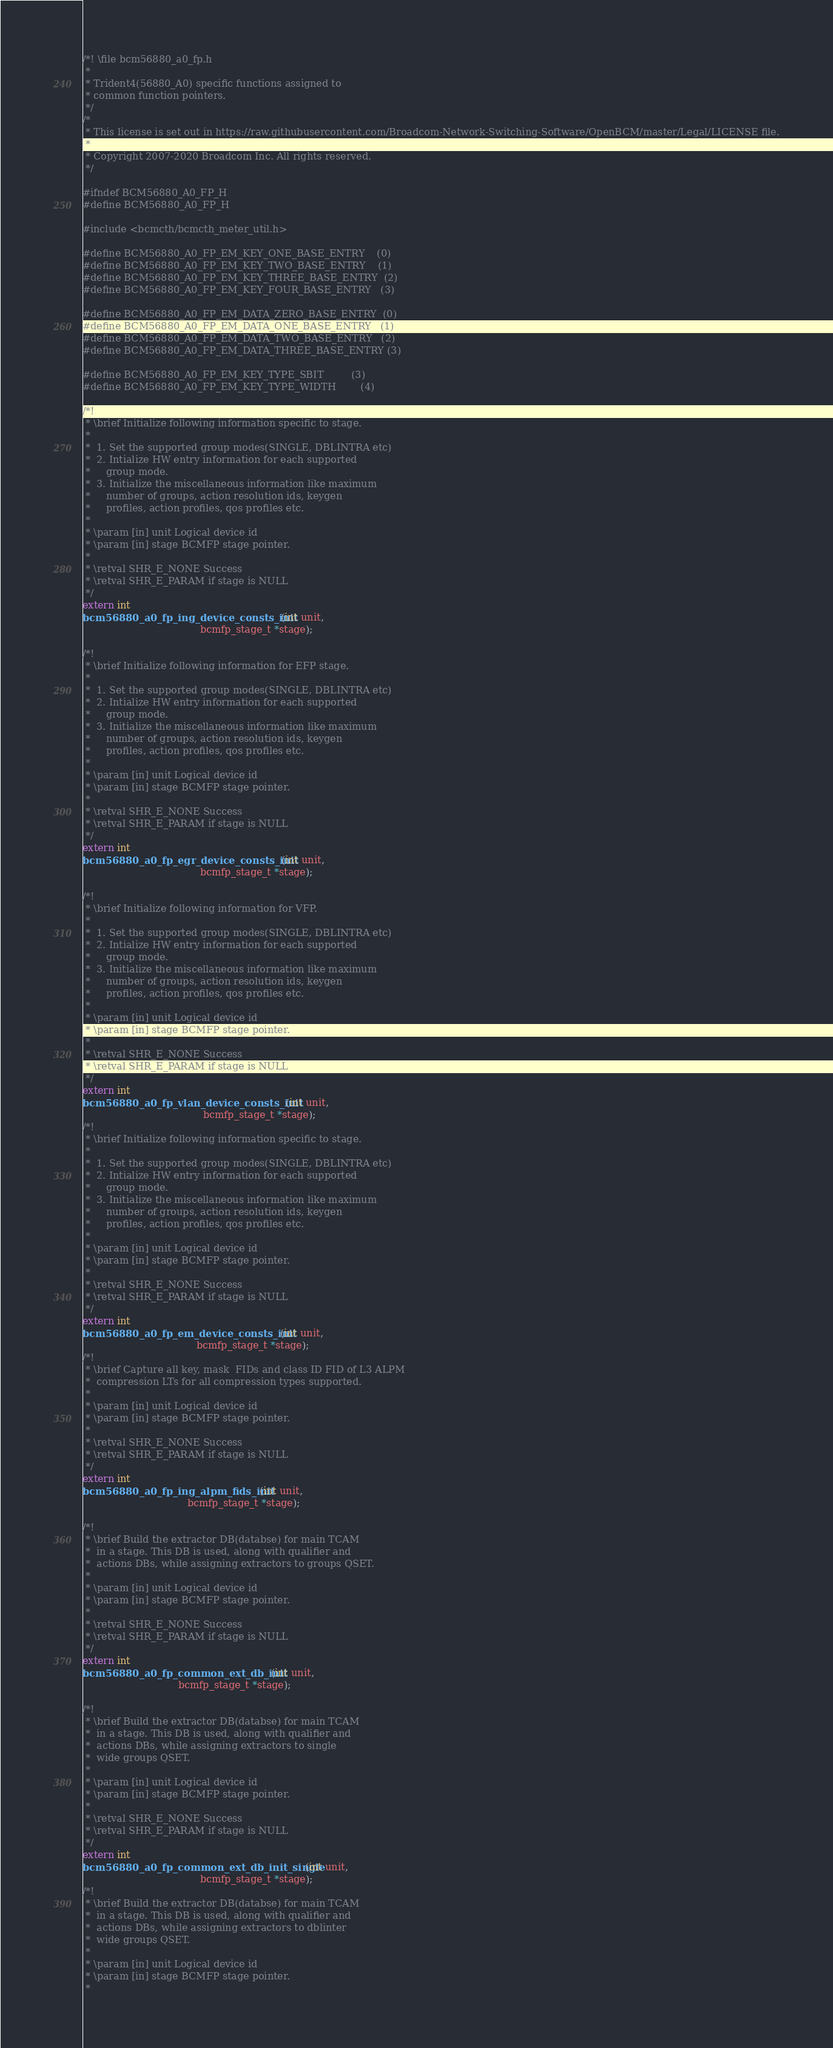Convert code to text. <code><loc_0><loc_0><loc_500><loc_500><_C_>/*! \file bcm56880_a0_fp.h
 *
 * Trident4(56880_A0) specific functions assigned to
 * common function pointers.
 */
/*
 * This license is set out in https://raw.githubusercontent.com/Broadcom-Network-Switching-Software/OpenBCM/master/Legal/LICENSE file.
 * 
 * Copyright 2007-2020 Broadcom Inc. All rights reserved.
 */

#ifndef BCM56880_A0_FP_H
#define BCM56880_A0_FP_H

#include <bcmcth/bcmcth_meter_util.h>

#define BCM56880_A0_FP_EM_KEY_ONE_BASE_ENTRY    (0)
#define BCM56880_A0_FP_EM_KEY_TWO_BASE_ENTRY    (1)
#define BCM56880_A0_FP_EM_KEY_THREE_BASE_ENTRY  (2)
#define BCM56880_A0_FP_EM_KEY_FOUR_BASE_ENTRY   (3)

#define BCM56880_A0_FP_EM_DATA_ZERO_BASE_ENTRY  (0)
#define BCM56880_A0_FP_EM_DATA_ONE_BASE_ENTRY   (1)
#define BCM56880_A0_FP_EM_DATA_TWO_BASE_ENTRY   (2)
#define BCM56880_A0_FP_EM_DATA_THREE_BASE_ENTRY (3)

#define BCM56880_A0_FP_EM_KEY_TYPE_SBIT         (3)
#define BCM56880_A0_FP_EM_KEY_TYPE_WIDTH        (4)

/*!
 * \brief Initialize following information specific to stage.
 *
 *  1. Set the supported group modes(SINGLE, DBLINTRA etc)
 *  2. Intialize HW entry information for each supported
 *     group mode.
 *  3. Initialize the miscellaneous information like maximum
 *     number of groups, action resolution ids, keygen
 *     profiles, action profiles, qos profiles etc.
 *
 * \param [in] unit Logical device id
 * \param [in] stage BCMFP stage pointer.
 *
 * \retval SHR_E_NONE Success
 * \retval SHR_E_PARAM if stage is NULL
 */
extern int
bcm56880_a0_fp_ing_device_consts_init(int unit,
                                      bcmfp_stage_t *stage);

/*!
 * \brief Initialize following information for EFP stage.
 *
 *  1. Set the supported group modes(SINGLE, DBLINTRA etc)
 *  2. Intialize HW entry information for each supported
 *     group mode.
 *  3. Initialize the miscellaneous information like maximum
 *     number of groups, action resolution ids, keygen
 *     profiles, action profiles, qos profiles etc.
 *
 * \param [in] unit Logical device id
 * \param [in] stage BCMFP stage pointer.
 *
 * \retval SHR_E_NONE Success
 * \retval SHR_E_PARAM if stage is NULL
 */
extern int
bcm56880_a0_fp_egr_device_consts_init(int unit,
                                      bcmfp_stage_t *stage);

/*!
 * \brief Initialize following information for VFP.
 *
 *  1. Set the supported group modes(SINGLE, DBLINTRA etc)
 *  2. Intialize HW entry information for each supported
 *     group mode.
 *  3. Initialize the miscellaneous information like maximum
 *     number of groups, action resolution ids, keygen
 *     profiles, action profiles, qos profiles etc.
 *
 * \param [in] unit Logical device id
 * \param [in] stage BCMFP stage pointer.
 *
 * \retval SHR_E_NONE Success
 * \retval SHR_E_PARAM if stage is NULL
 */
extern int
bcm56880_a0_fp_vlan_device_consts_init(int unit,
                                       bcmfp_stage_t *stage);
/*!
 * \brief Initialize following information specific to stage.
 *
 *  1. Set the supported group modes(SINGLE, DBLINTRA etc)
 *  2. Intialize HW entry information for each supported
 *     group mode.
 *  3. Initialize the miscellaneous information like maximum
 *     number of groups, action resolution ids, keygen
 *     profiles, action profiles, qos profiles etc.
 *
 * \param [in] unit Logical device id
 * \param [in] stage BCMFP stage pointer.
 *
 * \retval SHR_E_NONE Success
 * \retval SHR_E_PARAM if stage is NULL
 */
extern int
bcm56880_a0_fp_em_device_consts_init(int unit,
                                     bcmfp_stage_t *stage);
/*!
 * \brief Capture all key, mask  FIDs and class ID FID of L3 ALPM
 *  compression LTs for all compression types supported.
 *
 * \param [in] unit Logical device id
 * \param [in] stage BCMFP stage pointer.
 *
 * \retval SHR_E_NONE Success
 * \retval SHR_E_PARAM if stage is NULL
 */
extern int
bcm56880_a0_fp_ing_alpm_fids_init(int unit,
                                  bcmfp_stage_t *stage);

/*!
 * \brief Build the extractor DB(databse) for main TCAM
 *  in a stage. This DB is used, along with qualifier and
 *  actions DBs, while assigning extractors to groups QSET.
 *
 * \param [in] unit Logical device id
 * \param [in] stage BCMFP stage pointer.
 *
 * \retval SHR_E_NONE Success
 * \retval SHR_E_PARAM if stage is NULL
 */
extern int
bcm56880_a0_fp_common_ext_db_init(int unit,
                               bcmfp_stage_t *stage);

/*!
 * \brief Build the extractor DB(databse) for main TCAM
 *  in a stage. This DB is used, along with qualifier and
 *  actions DBs, while assigning extractors to single
 *  wide groups QSET.
 *
 * \param [in] unit Logical device id
 * \param [in] stage BCMFP stage pointer.
 *
 * \retval SHR_E_NONE Success
 * \retval SHR_E_PARAM if stage is NULL
 */
extern int
bcm56880_a0_fp_common_ext_db_init_single(int unit,
                                      bcmfp_stage_t *stage);
/*!
 * \brief Build the extractor DB(databse) for main TCAM
 *  in a stage. This DB is used, along with qualifier and
 *  actions DBs, while assigning extractors to dblinter
 *  wide groups QSET.
 *
 * \param [in] unit Logical device id
 * \param [in] stage BCMFP stage pointer.
 *</code> 